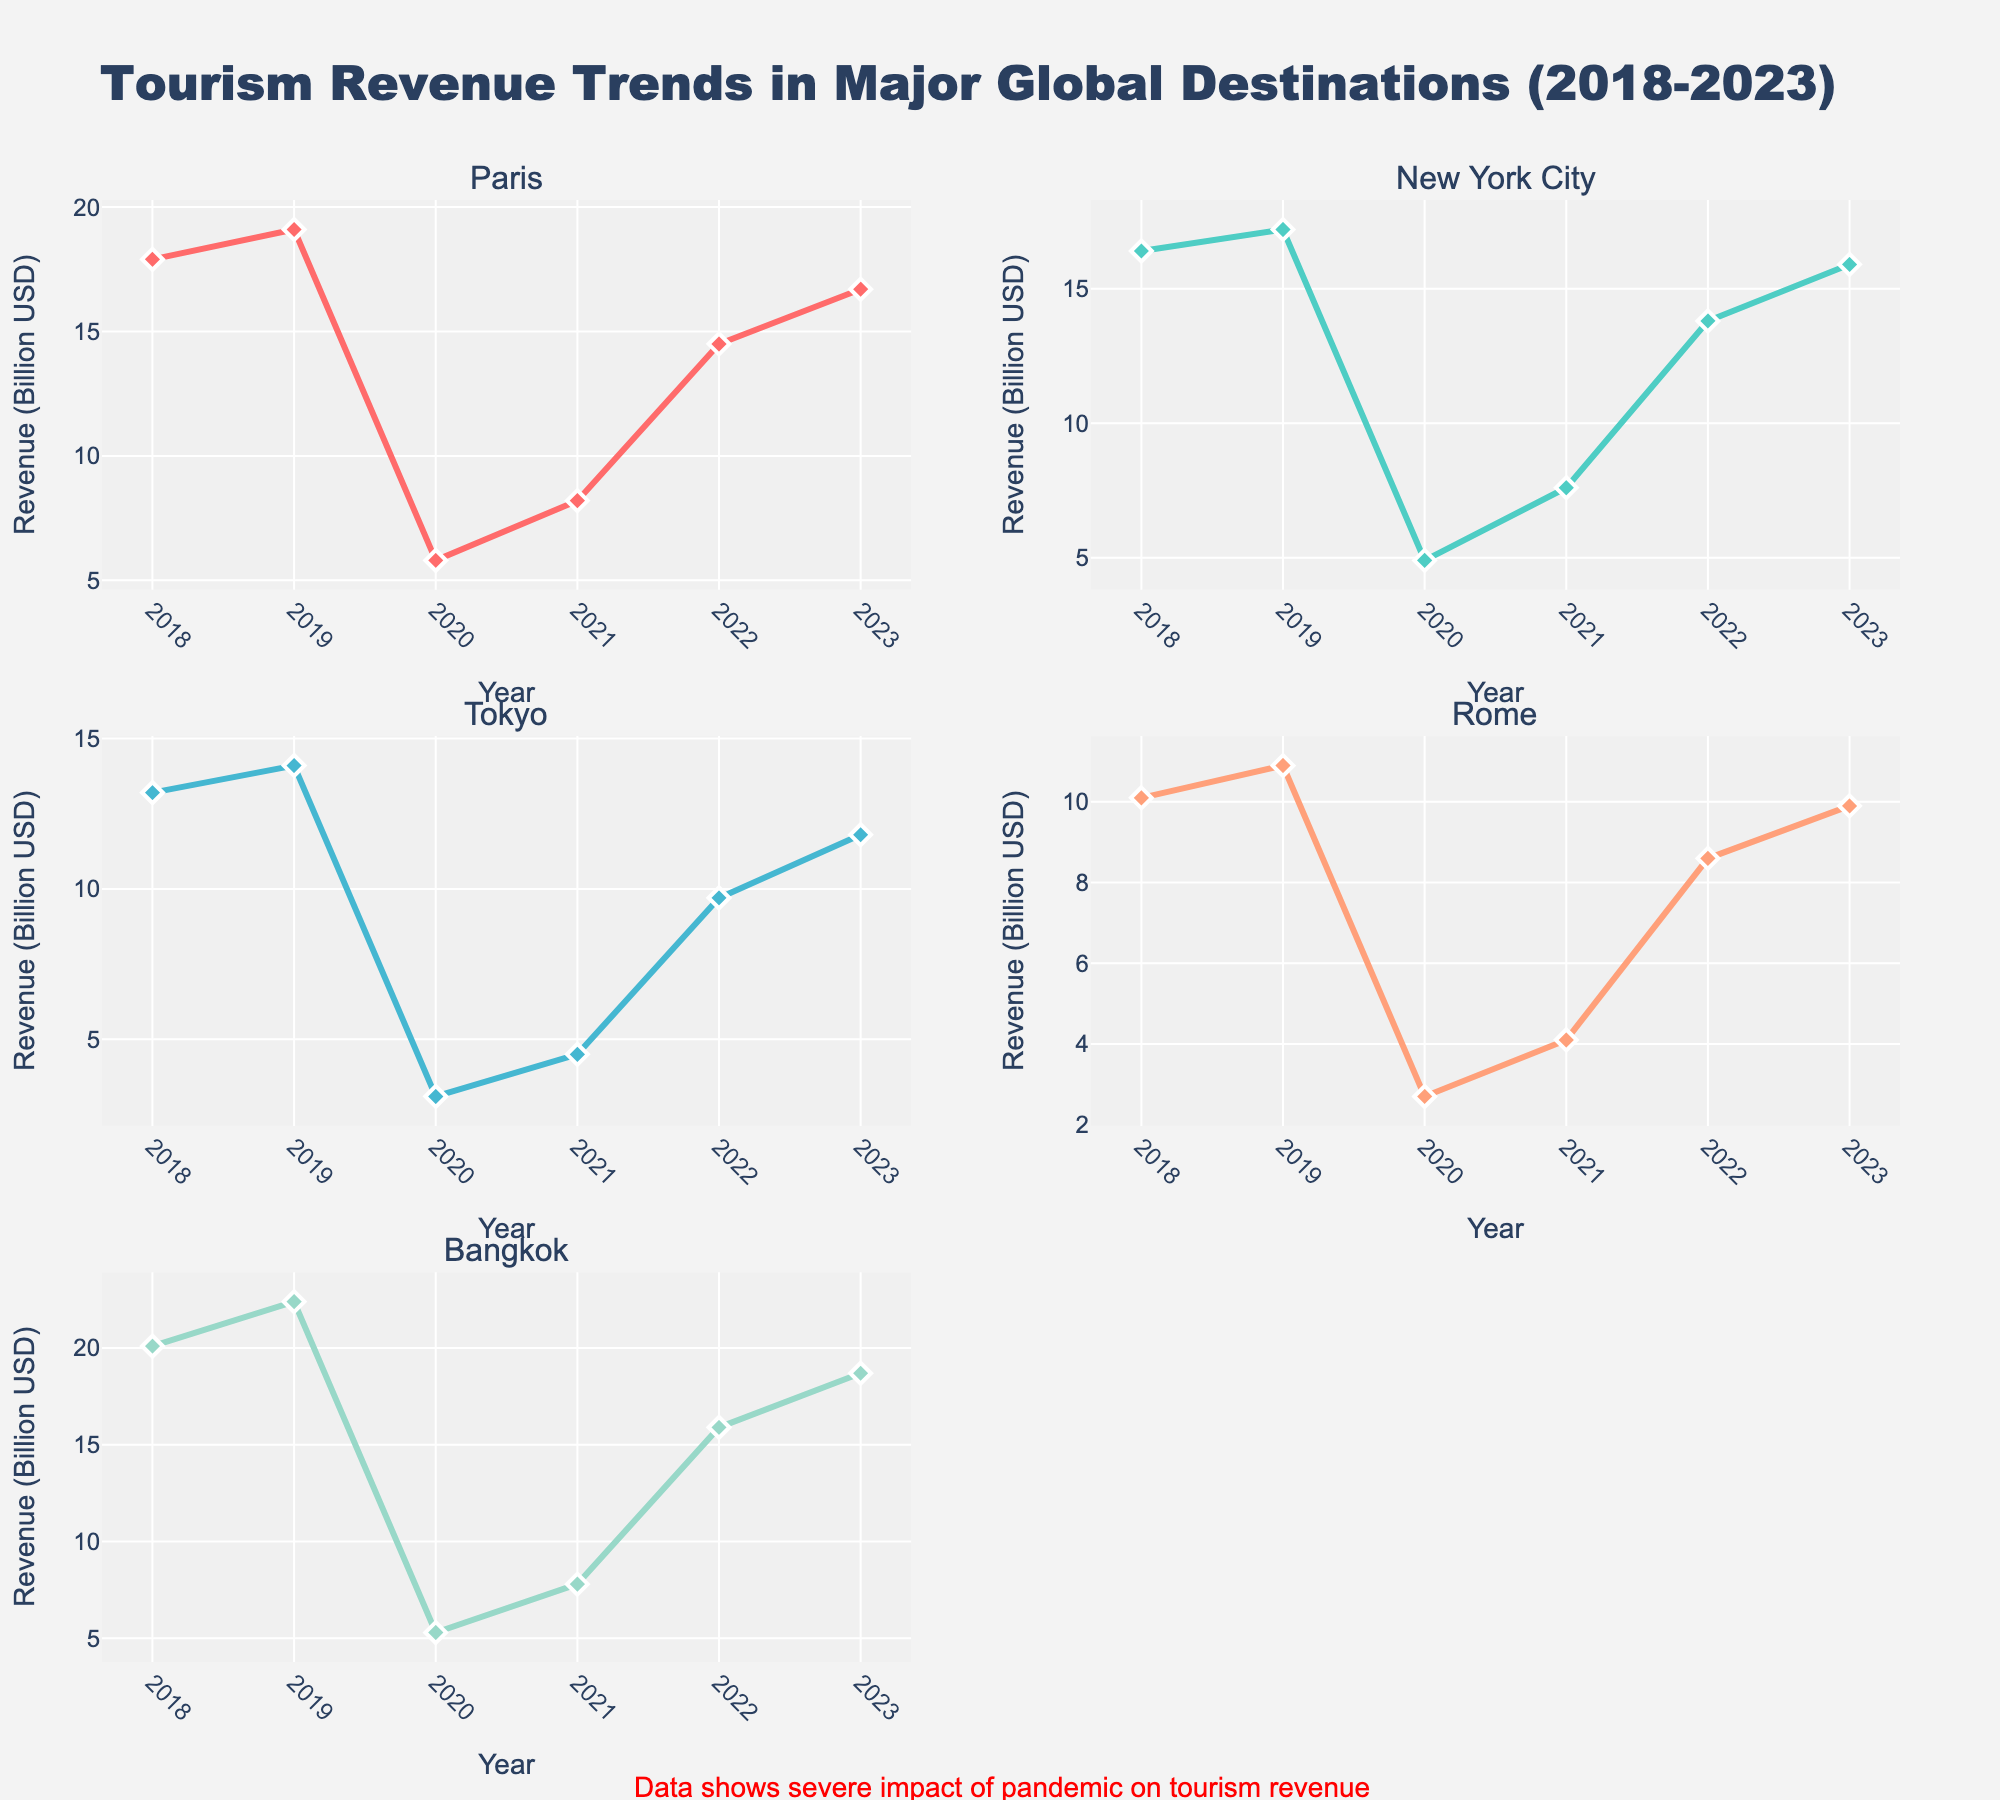What are the age groups represented in the "Office Supplies" category? To determine this, you need to refer to the x-axis labels in the subplot for "Office Supplies". The x-axis denotes different age groups.
Answer: 18-24, 25-34, 35-44, 45-54 Which category has the highest average spend for customers aged 25-34? Look at the subplots, locate the 25-34 age group bubble for each category, and compare their y-axis values (average spend). The highest y-axis value will indicate the category with the highest average spend.
Answer: Furniture How many customer counts are represented by the largest bubble in the "Electronics" category? Identify the largest bubble in the "Electronics" subplot. Hover over the bubble to see the tooltip that provides customer count information.
Answer: 1600 Which gender appears most frequently in the "Marketing Materials" category? Hover over the bubbles in the "Marketing Materials" subplot and read the text in the tooltip that mentions "Gender". Count occurrences of "Male" and "Female".
Answer: Male For the "Office Supplies" category, which purchase frequency is associated with the highest average spend? Move through the "Office Supplies" subplot and note the color of each bubble as it corresponds to the purchase frequency. Find the bubble with the highest position on the y-axis (average spend) and check its color to determine the purchase frequency.
Answer: Bi-weekly Which age group has the lowest average spend in the "Furniture" category? In the "Furniture" subplot, examine the y-axis values (average spend) for each age group and identify the lowest one.
Answer: 25-34 How does the customer count compare between the 35-44 age group in "Office Supplies" and "Marketing Materials"? Find the bubbles representing the 35-44 age group in both "Office Supplies" and "Marketing Materials". Hover over each bubble to see the customer count in the tooltips and compare them.
Answer: 2200 (Office Supplies) vs. 1700 (Marketing Materials) What is the most common purchase frequency in the "Electronics" category? Look at the colors of bubbles in the "Electronics" subplot. Identify which color appears most frequently and refer to the color bar to determine the purchase frequency.
Answer: Quarterly Which category has the most diverse age groups represented? Count the number of unique age groups in each subplot. The category with the highest count has the most diverse age groups.
Answer: Office Supplies What is the average spend of the 45-54 female group in "Electronics"? Locate the bubble for the 45-54 female group in the "Electronics" subplot and read its position on the y-axis.
Answer: 275 